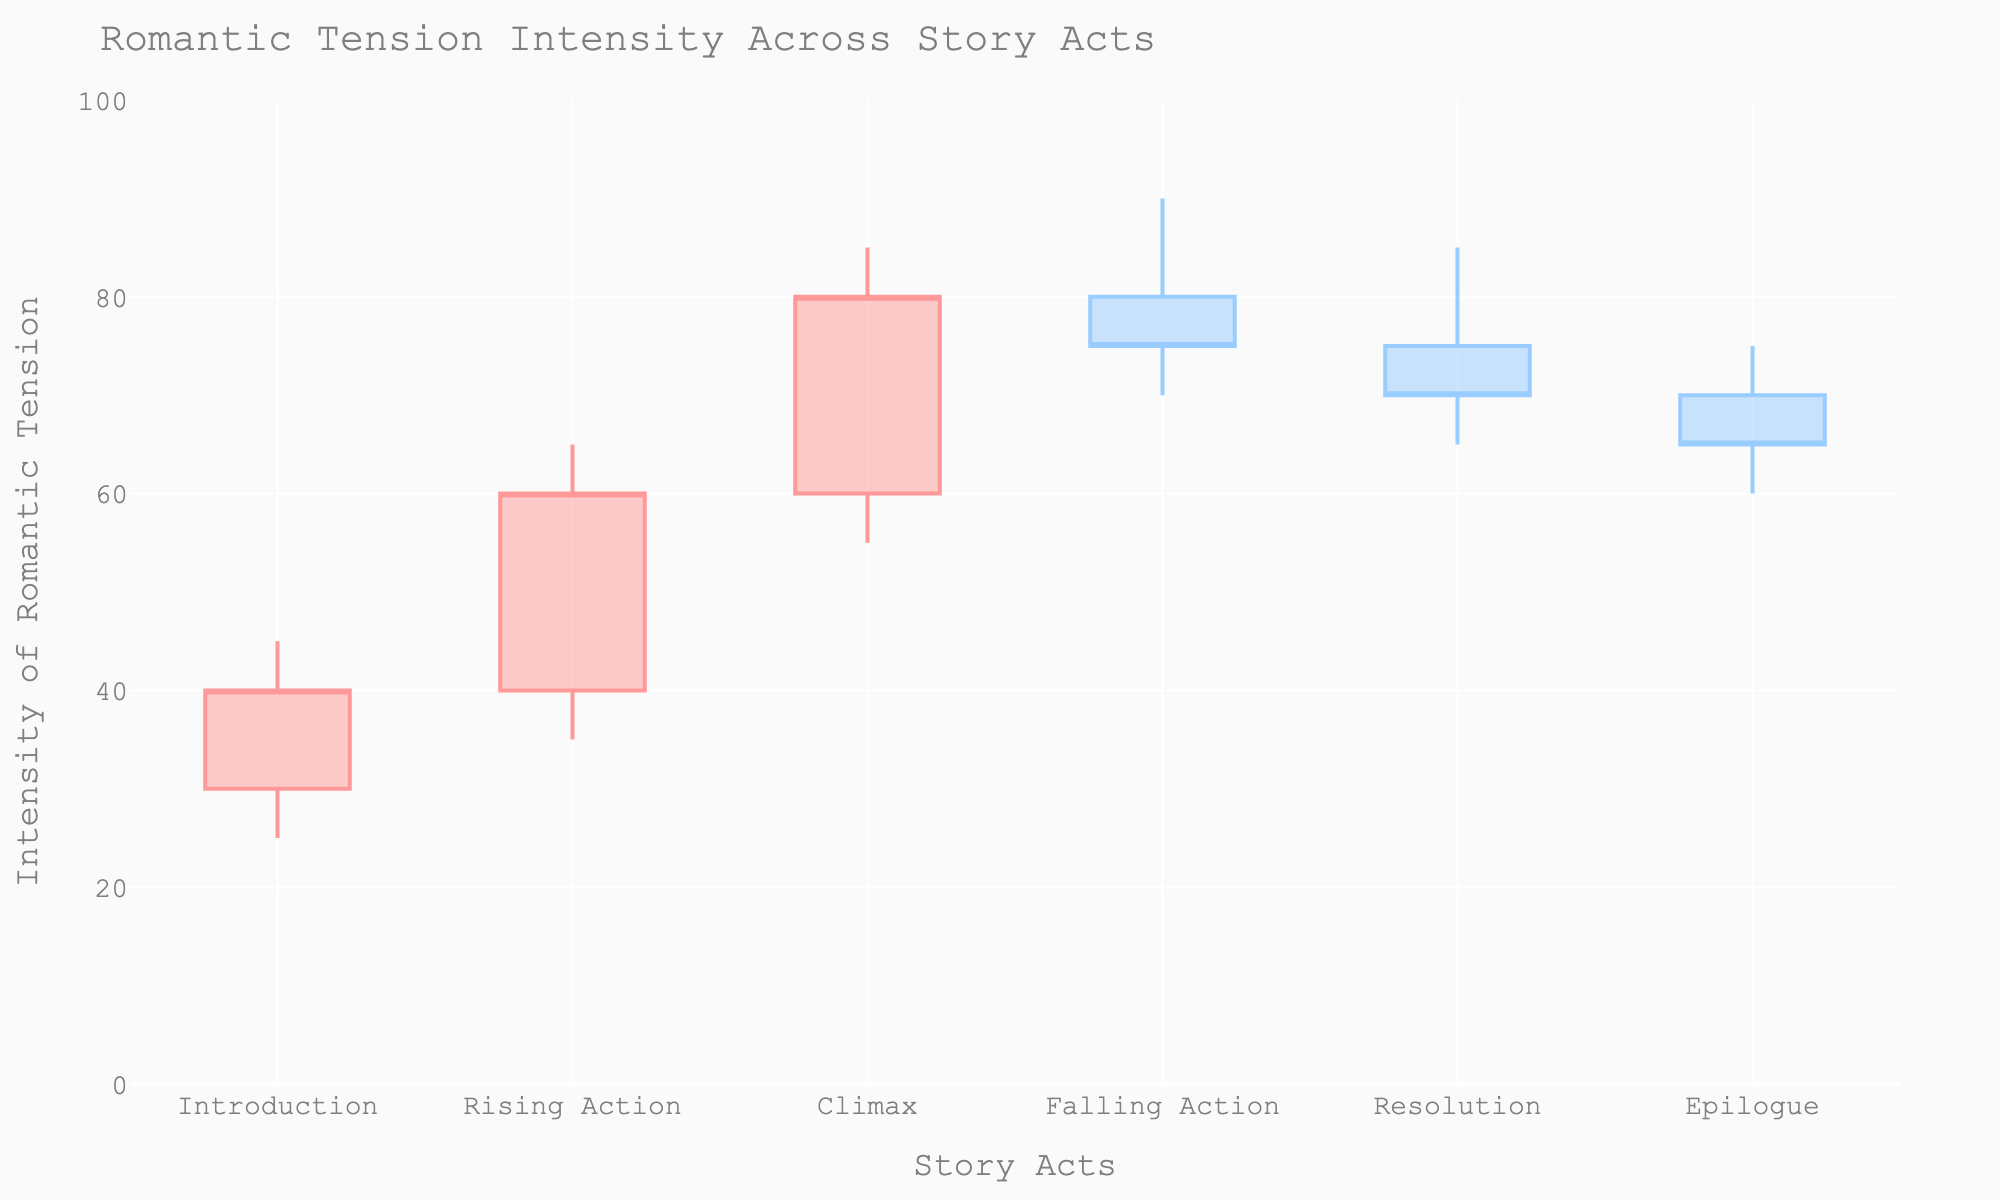What's the title of the chart? At the top of the chart, the title "Romantic Tension Intensity Across Story Acts" is displayed prominently.
Answer: Romantic Tension Intensity Across Story Acts What is the intensity of romantic tension at the end of the Climax act? The end (Close value) of the Climax act shows the intensity at 80.
Answer: 80 Which act has the highest peak of romantic tension? By examining the highest point (High value) in each candlestick, the Falling Action has the highest value of 90.
Answer: Falling Action What are the Open and Close values for the Introduction act? The values for Open and Close in the Introduction act can be identified by looking at the candlestick for that act.
Answer: Open: 30, Close: 40 How does the intensity of romantic tension change from Rising Action to Climax? From Rising Action to Climax, the Close value increases from 60 to 80, indicating a rise in romantic tension.
Answer: Increase from 60 to 80 Which act shows the greatest decrease in tension from high to low? By comparing the difference between the High and Low values, the largest decrease is in the Climax act (85 - 55 = 30).
Answer: Climax How many acts show an increase in romantic tension by the end? A candlestick that ends higher than it opens indicates an increase. There are 4 such candlesticks: Introduction, Rising Action, Climax, and Falling Action.
Answer: 4 acts Which act has the smallest range of romantic tension? Calculate the range (High - Low); the act with the smallest difference is the Epilogue (75 - 60 = 15).
Answer: Epilogue On which act does the romantic tension have the least variability? Comparing the range of values indicates that the Epilogue act has the least variability with a range of 15.
Answer: Epilogue 